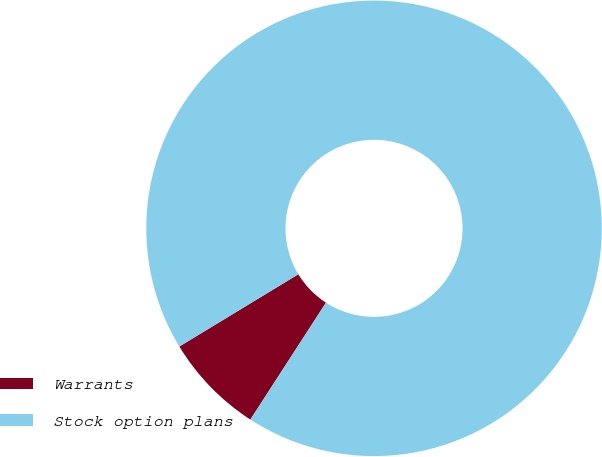Convert chart to OTSL. <chart><loc_0><loc_0><loc_500><loc_500><pie_chart><fcel>Warrants<fcel>Stock option plans<nl><fcel>7.18%<fcel>92.82%<nl></chart> 